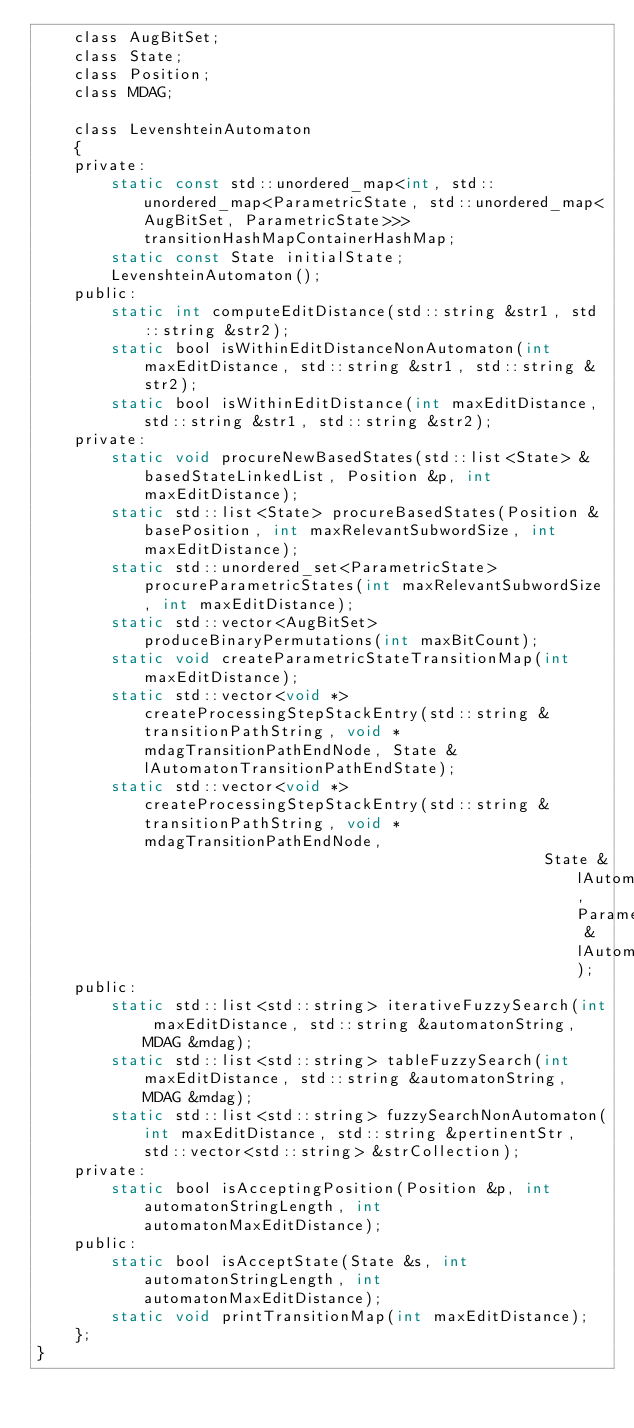<code> <loc_0><loc_0><loc_500><loc_500><_C_>    class AugBitSet;
    class State;
    class Position;
    class MDAG;

    class LevenshteinAutomaton
    {
    private:
        static const std::unordered_map<int, std::unordered_map<ParametricState, std::unordered_map<AugBitSet, ParametricState>>> transitionHashMapContainerHashMap;
        static const State initialState;
        LevenshteinAutomaton();
    public:
        static int computeEditDistance(std::string &str1, std::string &str2);
        static bool isWithinEditDistanceNonAutomaton(int maxEditDistance, std::string &str1, std::string &str2);
        static bool isWithinEditDistance(int maxEditDistance, std::string &str1, std::string &str2);
    private:
        static void procureNewBasedStates(std::list<State> &basedStateLinkedList, Position &p, int maxEditDistance);
        static std::list<State> procureBasedStates(Position &basePosition, int maxRelevantSubwordSize, int maxEditDistance);
        static std::unordered_set<ParametricState> procureParametricStates(int maxRelevantSubwordSize, int maxEditDistance);
        static std::vector<AugBitSet> produceBinaryPermutations(int maxBitCount);
        static void createParametricStateTransitionMap(int maxEditDistance);
        static std::vector<void *> createProcessingStepStackEntry(std::string &transitionPathString, void *mdagTransitionPathEndNode, State &lAutomatonTransitionPathEndState);
        static std::vector<void *> createProcessingStepStackEntry(std::string &transitionPathString, void *mdagTransitionPathEndNode,
                                                       State &lAutomatonTransitionPathEndState, ParametricState &lAutomatonTransitionPathEndParametricState);
    public:
        static std::list<std::string> iterativeFuzzySearch(int maxEditDistance, std::string &automatonString, MDAG &mdag);
        static std::list<std::string> tableFuzzySearch(int maxEditDistance, std::string &automatonString, MDAG &mdag);
        static std::list<std::string> fuzzySearchNonAutomaton(int maxEditDistance, std::string &pertinentStr, std::vector<std::string> &strCollection);
    private:
        static bool isAcceptingPosition(Position &p, int automatonStringLength, int automatonMaxEditDistance);
    public:
        static bool isAcceptState(State &s, int automatonStringLength, int automatonMaxEditDistance);
        static void printTransitionMap(int maxEditDistance);
    };
}</code> 